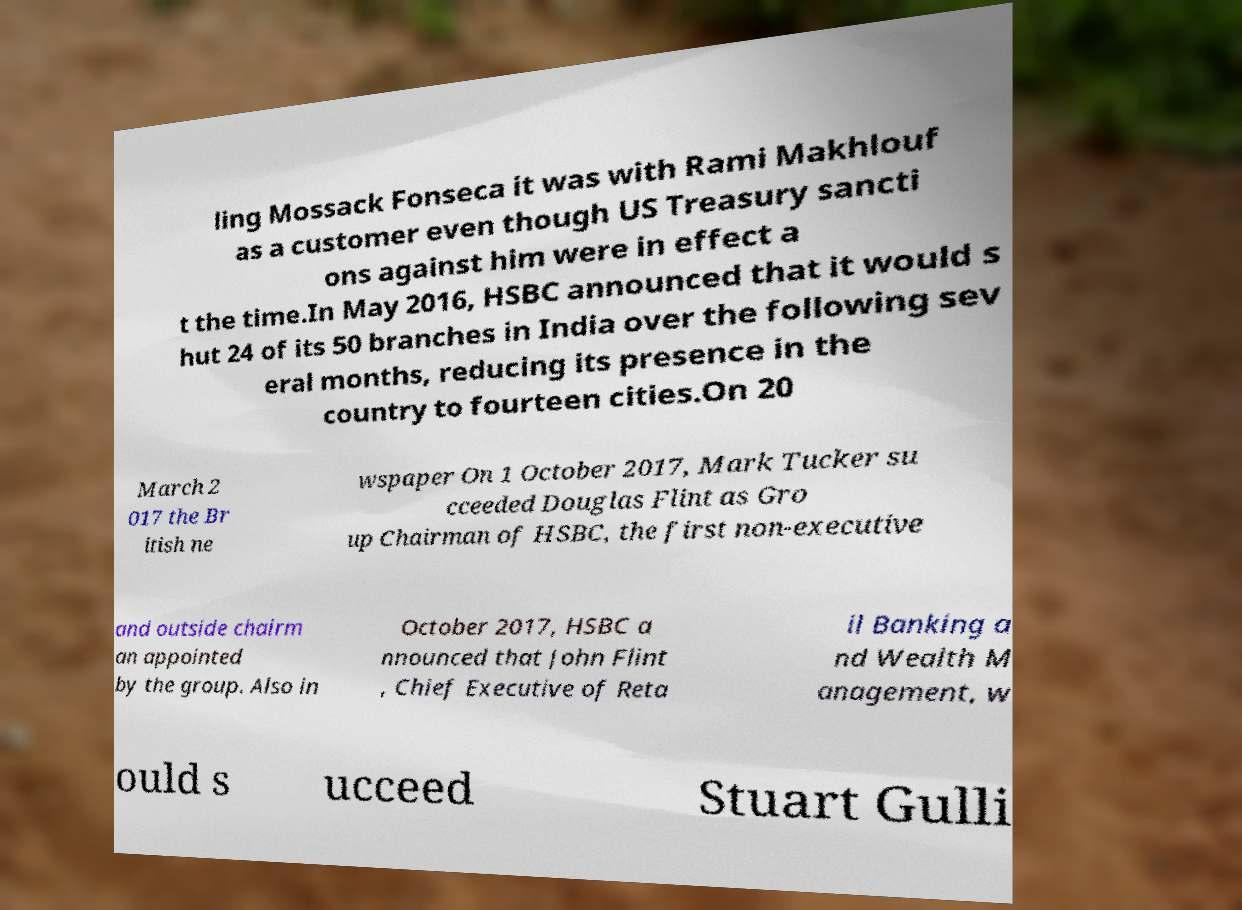Can you accurately transcribe the text from the provided image for me? ling Mossack Fonseca it was with Rami Makhlouf as a customer even though US Treasury sancti ons against him were in effect a t the time.In May 2016, HSBC announced that it would s hut 24 of its 50 branches in India over the following sev eral months, reducing its presence in the country to fourteen cities.On 20 March 2 017 the Br itish ne wspaper On 1 October 2017, Mark Tucker su cceeded Douglas Flint as Gro up Chairman of HSBC, the first non-executive and outside chairm an appointed by the group. Also in October 2017, HSBC a nnounced that John Flint , Chief Executive of Reta il Banking a nd Wealth M anagement, w ould s ucceed Stuart Gulli 